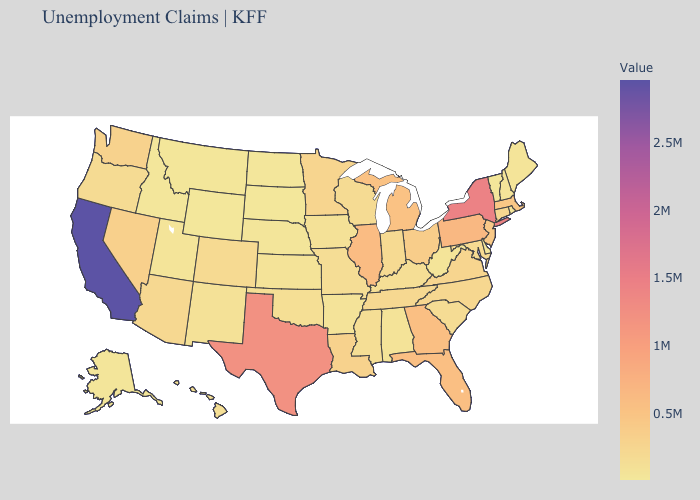Which states have the lowest value in the USA?
Quick response, please. Wyoming. Is the legend a continuous bar?
Answer briefly. Yes. Which states have the lowest value in the MidWest?
Give a very brief answer. South Dakota. 